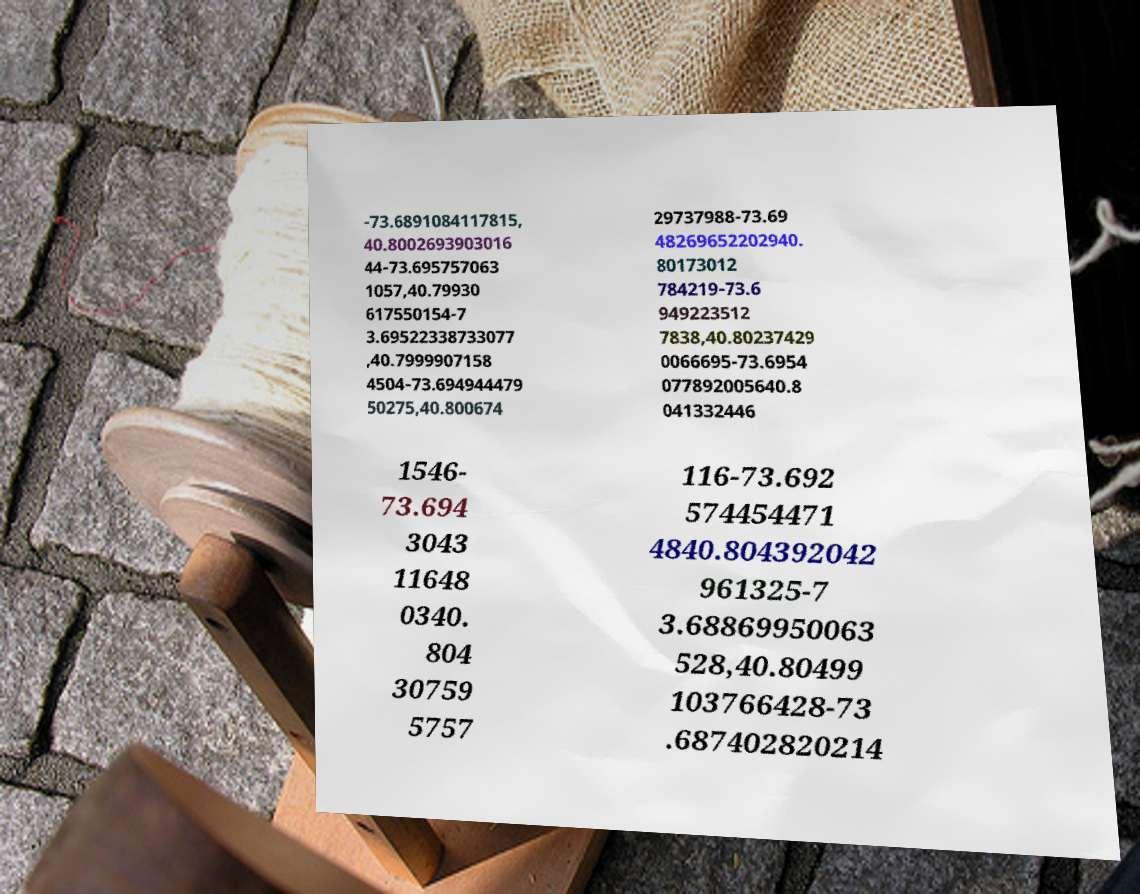There's text embedded in this image that I need extracted. Can you transcribe it verbatim? -73.6891084117815, 40.8002693903016 44-73.695757063 1057,40.79930 617550154-7 3.69522338733077 ,40.7999907158 4504-73.694944479 50275,40.800674 29737988-73.69 48269652202940. 80173012 784219-73.6 949223512 7838,40.80237429 0066695-73.6954 077892005640.8 041332446 1546- 73.694 3043 11648 0340. 804 30759 5757 116-73.692 574454471 4840.804392042 961325-7 3.68869950063 528,40.80499 103766428-73 .687402820214 